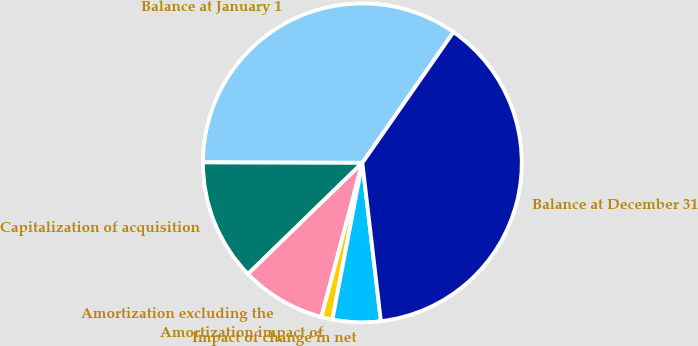<chart> <loc_0><loc_0><loc_500><loc_500><pie_chart><fcel>Balance at January 1<fcel>Capitalization of acquisition<fcel>Amortization excluding the<fcel>Amortization impact of<fcel>Impact of change in net<fcel>Balance at December 31<nl><fcel>34.64%<fcel>12.32%<fcel>8.59%<fcel>1.13%<fcel>4.86%<fcel>38.45%<nl></chart> 